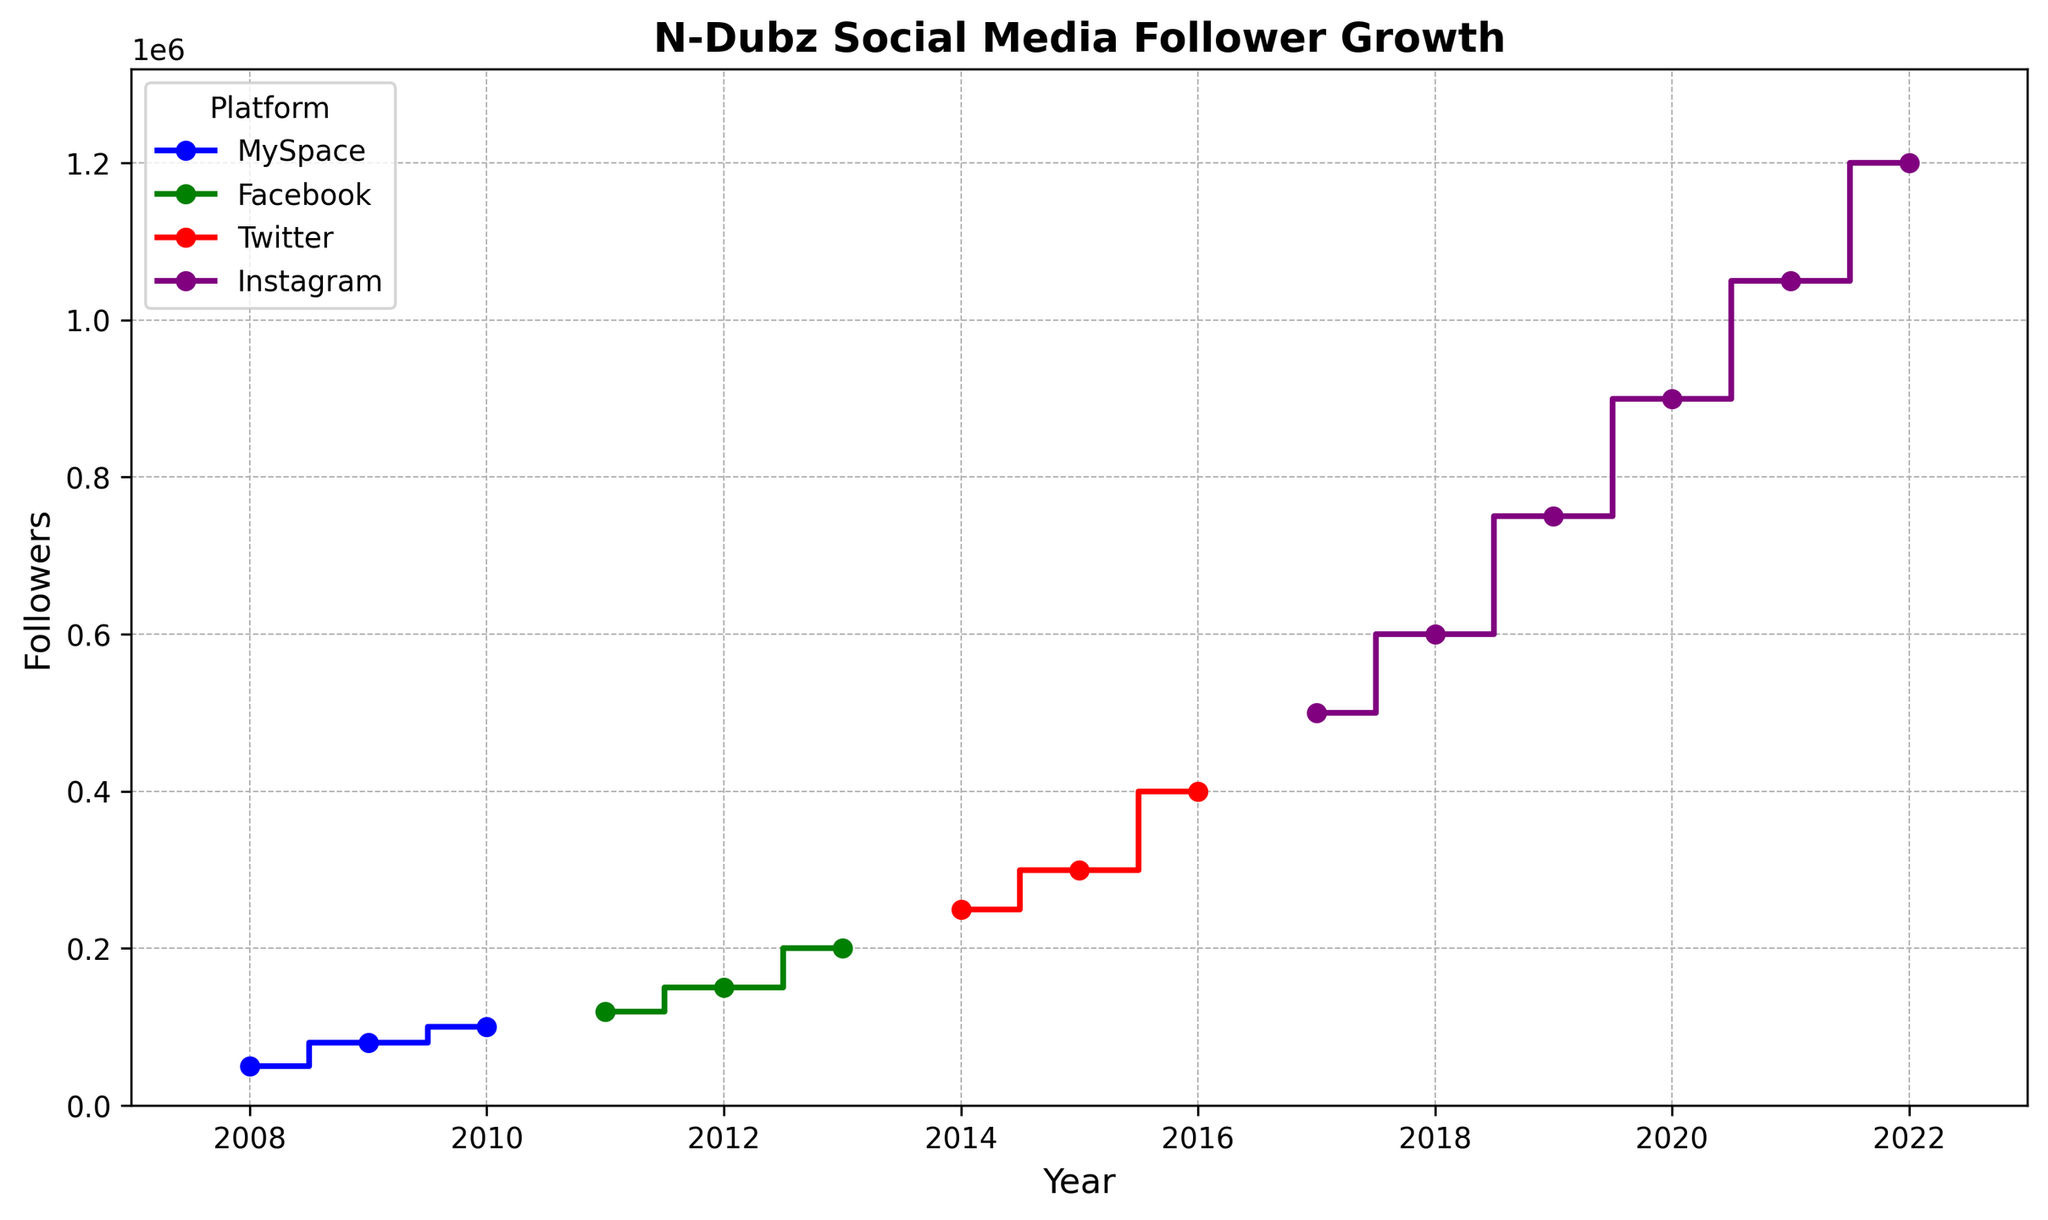What year did N-Dubz accumulate the highest number of followers on MySpace? The plot shows the number of followers over the years for each platform. For MySpace, the highest number is shown in 2010.
Answer: 2010 In which year did N-Dubz's Instagram follower count surpass 1 million? The plot shows the follower count for Instagram as lines connecting yearly points. The line surpasses 1 million in the year 2021.
Answer: 2021 Did N-Dubz have more followers on Facebook or Twitter in 2014? The plot has separate colored lines for different platforms' follower growth. For Facebook, the latest data point in 2013 is 200,000 followers. For Twitter, the 2014 data point shows 250,000 followers.
Answer: Twitter How many total Instagram followers did N-Dubz gain from 2017 to 2022? List down the Instagram follower counts for the years 2017 to 2022: 500,000, 600,000, 750,000, 900,000, 1,050,000, and 1,200,000. The total gain is calculated by summing these values: \( (600,000 - 500,000) + (750,000 - 600,000) + (900,000 - 750,000) + (1,050,000 - 900,000) + (1,200,000 - 1,050,000) = 700,000 \).
Answer: 700,000 In which year did N-Dubz switch from MySpace to Facebook for tracking followers, as seen in the figure? Locate the last year where MySpace has data (2010) and find the first year for Facebook (2011).
Answer: 2011 Between 2016 and 2019, which platform experienced the highest total follower growth? Compare follower growth between platforms using the plot:
- Facebook ends at 2013 with 200,000.
- Twitter from 2015 (300,000) to 2016 (400,000): 100,000.
- Instagram from 2017 (500,000) to 2019 (750,000): 250,000.
Answer: Instagram In which year did N-Dubz see the largest single-year increase in Twitter followers? The plot shows Twitter followers yearly: 2014 (250,000), 2015 (300,000), 2016 (400,000). The largest single-year increase is from 2015 to 2016 (400,000 - 300,000 = 100,000).
Answer: 2016 Which platform colors showed the steepest increase in a single year visually? Identify the color with the sharpest slope. The steepest slope appears along the Instagram line, particularly going from 2019 (750,000) to 2020 (900,000).
Answer: Purple (Instagram) 